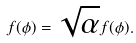Convert formula to latex. <formula><loc_0><loc_0><loc_500><loc_500>f ( \phi ) = \sqrt { \alpha } f ( \phi ) .</formula> 